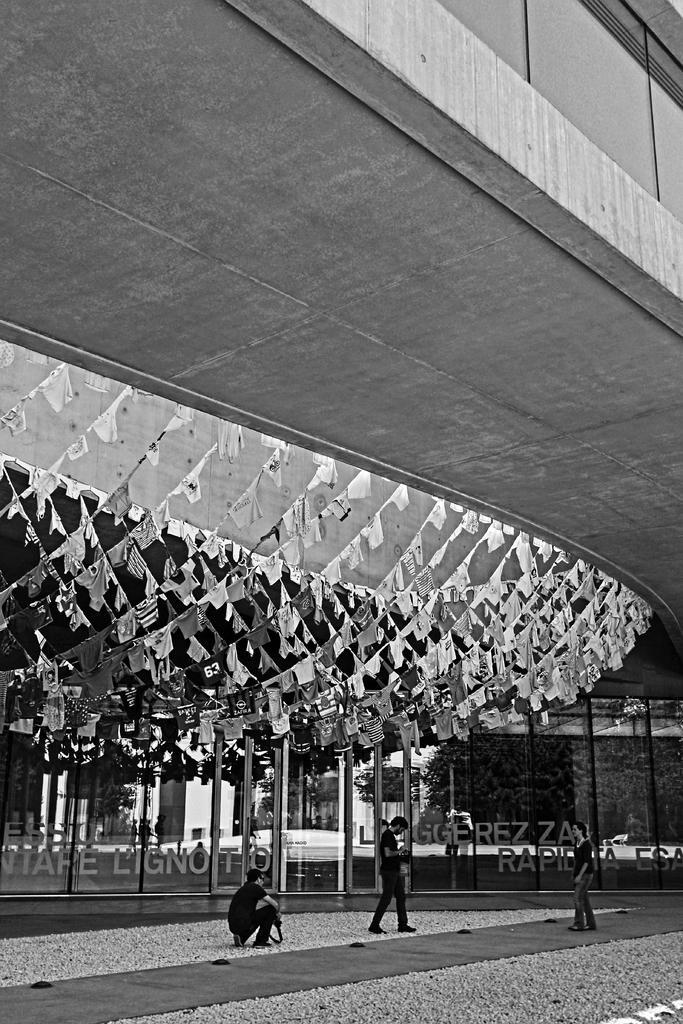Could you give a brief overview of what you see in this image? In this picture we can see three people on the ground, decorative flags, building and in the background we can see trees, some objects. 